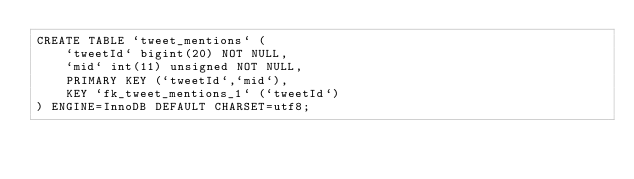<code> <loc_0><loc_0><loc_500><loc_500><_SQL_>CREATE TABLE `tweet_mentions` (
    `tweetId` bigint(20) NOT NULL,
    `mid` int(11) unsigned NOT NULL,
    PRIMARY KEY (`tweetId`,`mid`),
    KEY `fk_tweet_mentions_1` (`tweetId`)
) ENGINE=InnoDB DEFAULT CHARSET=utf8;
</code> 